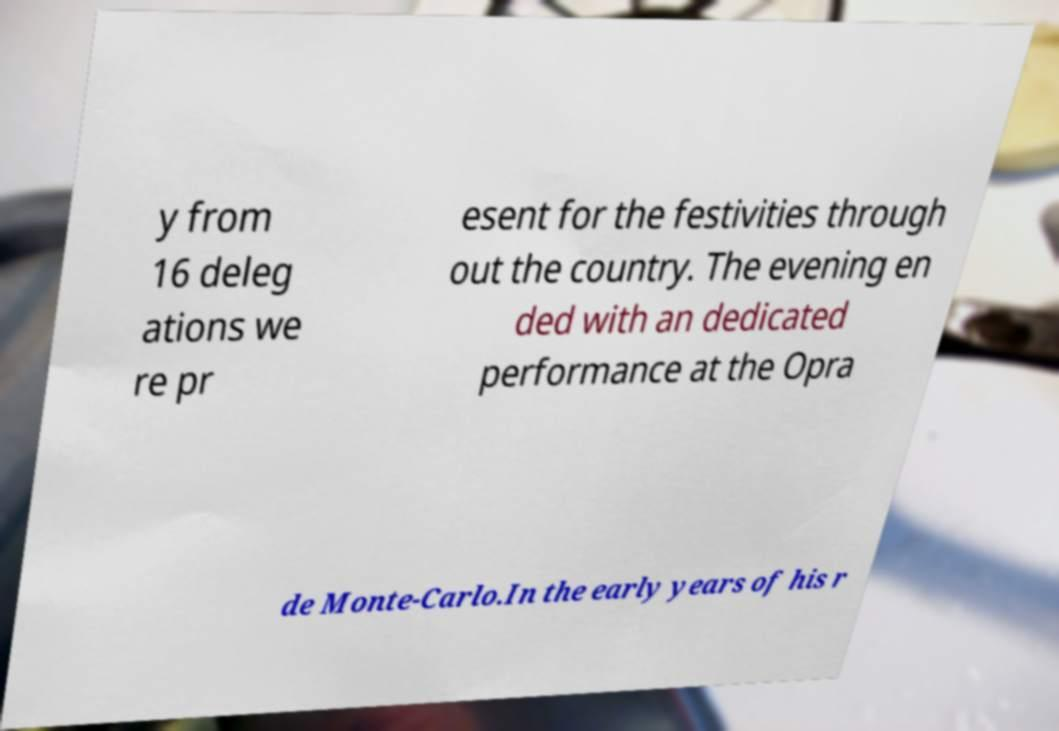Please identify and transcribe the text found in this image. y from 16 deleg ations we re pr esent for the festivities through out the country. The evening en ded with an dedicated performance at the Opra de Monte-Carlo.In the early years of his r 